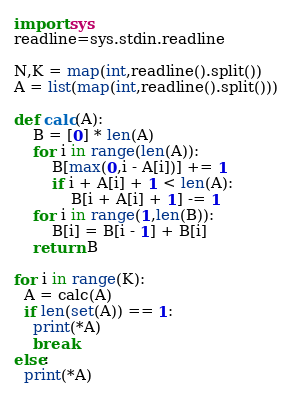<code> <loc_0><loc_0><loc_500><loc_500><_Python_>import sys
readline=sys.stdin.readline

N,K = map(int,readline().split())
A = list(map(int,readline().split()))

def calc(A):
    B = [0] * len(A)
    for i in range(len(A)):
        B[max(0,i - A[i])] += 1
        if i + A[i] + 1 < len(A):
            B[i + A[i] + 1] -= 1
    for i in range(1,len(B)):
        B[i] = B[i - 1] + B[i]
    return B

for i in range(K):
  A = calc(A)
  if len(set(A)) == 1:
    print(*A)
    break
else:
  print(*A)

</code> 